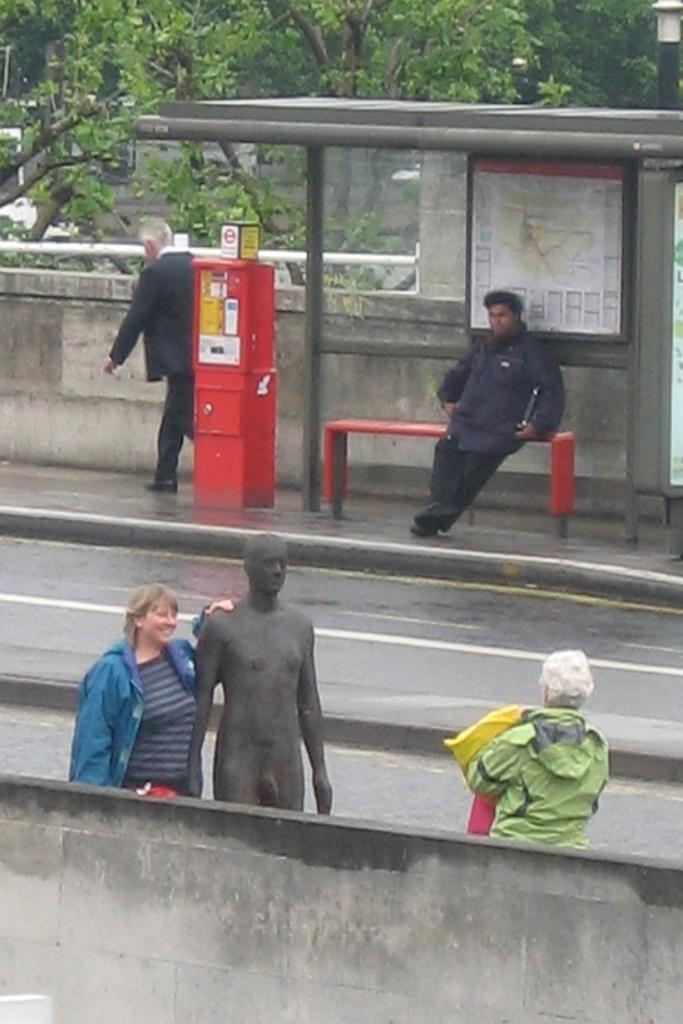What is located at the bottom of the image? There is a statue at the bottom of the image. Who or what else can be seen in the image? There are people in the image. What type of infrastructure is visible in the image? There is a road and a bus stand in the image. What can be seen in the background of the image? There are trees and a booth in the background of the image. What type of oatmeal is being served in the basket in the image? There is no oatmeal or basket present in the image. Can you tell me how many snakes are slithering around the statue in the image? There are no snakes present in the image; it features a statue, people, a road, a bus stand, trees, and a booth. 